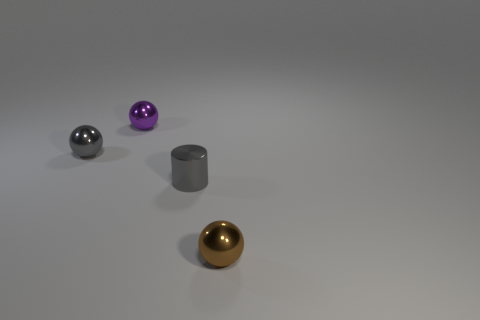There is a gray shiny object right of the metal sphere behind the gray shiny object on the left side of the small cylinder; how big is it?
Keep it short and to the point. Small. There is a ball right of the gray cylinder; is its size the same as the small purple metal ball?
Provide a succinct answer. Yes. What number of other objects are there of the same material as the gray sphere?
Keep it short and to the point. 3. Are there more large metallic blocks than small purple spheres?
Your response must be concise. No. What material is the gray thing on the right side of the purple ball that is left of the gray object in front of the gray metal sphere?
Provide a short and direct response. Metal. Is there a tiny shiny object that has the same color as the cylinder?
Ensure brevity in your answer.  Yes. There is a purple shiny thing that is the same size as the brown object; what is its shape?
Your response must be concise. Sphere. Is the number of large purple metallic cylinders less than the number of gray metal balls?
Offer a terse response. Yes. How many gray shiny things have the same size as the brown thing?
Provide a short and direct response. 2. The tiny object that is the same color as the shiny cylinder is what shape?
Your answer should be very brief. Sphere. 